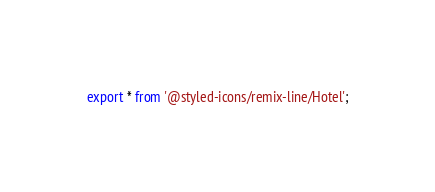<code> <loc_0><loc_0><loc_500><loc_500><_JavaScript_>export * from '@styled-icons/remix-line/Hotel';
</code> 